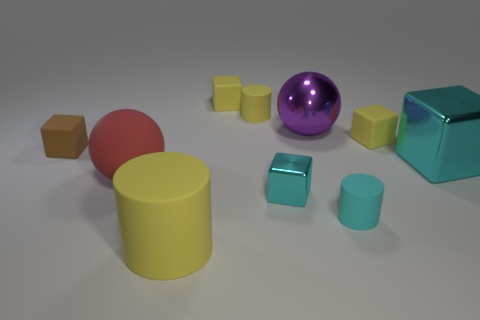What is the shape of the object that appears most frequently in the image? The most prevalent shape in this image is the cube, found in three distinct sizes and various colors including teal, brown, and yellow. 